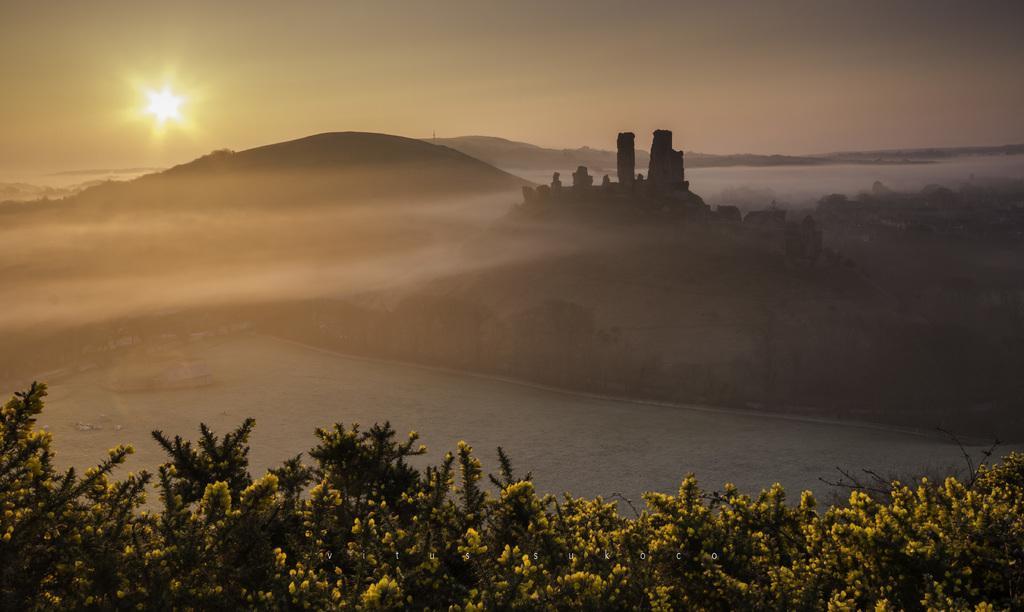Can you describe this image briefly? This image is clicked outside. At the bottom, we can see many plants along with yellow flowers. In the middle, there is water. In the background, there are mountains. At the top, there is sky. And we can see the sun in the sky. 